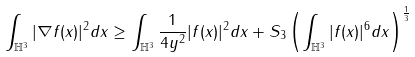Convert formula to latex. <formula><loc_0><loc_0><loc_500><loc_500>\int _ { \mathbb { H } ^ { 3 } } | \nabla f ( x ) | ^ { 2 } d x \geq \int _ { \mathbb { H } ^ { 3 } } \frac { 1 } { 4 y ^ { 2 } } | f ( x ) | ^ { 2 } d x + S _ { 3 } \left ( \int _ { \mathbb { H } ^ { 3 } } | f ( x ) | ^ { 6 } d x \right ) ^ { \frac { 1 } { 3 } }</formula> 